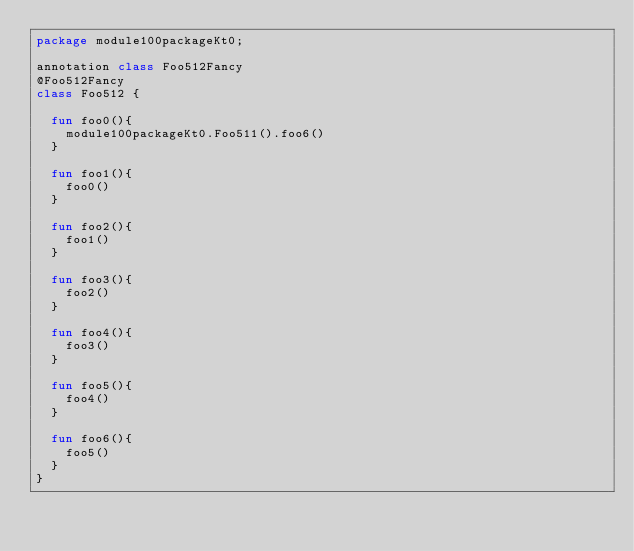Convert code to text. <code><loc_0><loc_0><loc_500><loc_500><_Kotlin_>package module100packageKt0;

annotation class Foo512Fancy
@Foo512Fancy
class Foo512 {

  fun foo0(){
    module100packageKt0.Foo511().foo6()
  }

  fun foo1(){
    foo0()
  }

  fun foo2(){
    foo1()
  }

  fun foo3(){
    foo2()
  }

  fun foo4(){
    foo3()
  }

  fun foo5(){
    foo4()
  }

  fun foo6(){
    foo5()
  }
}</code> 